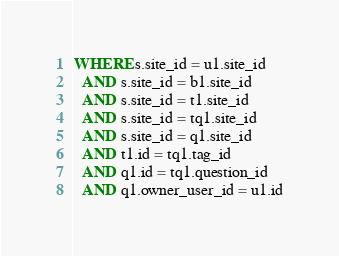Convert code to text. <code><loc_0><loc_0><loc_500><loc_500><_SQL_>WHERE s.site_id = u1.site_id
  AND s.site_id = b1.site_id
  AND s.site_id = t1.site_id
  AND s.site_id = tq1.site_id
  AND s.site_id = q1.site_id
  AND t1.id = tq1.tag_id
  AND q1.id = tq1.question_id
  AND q1.owner_user_id = u1.id</code> 